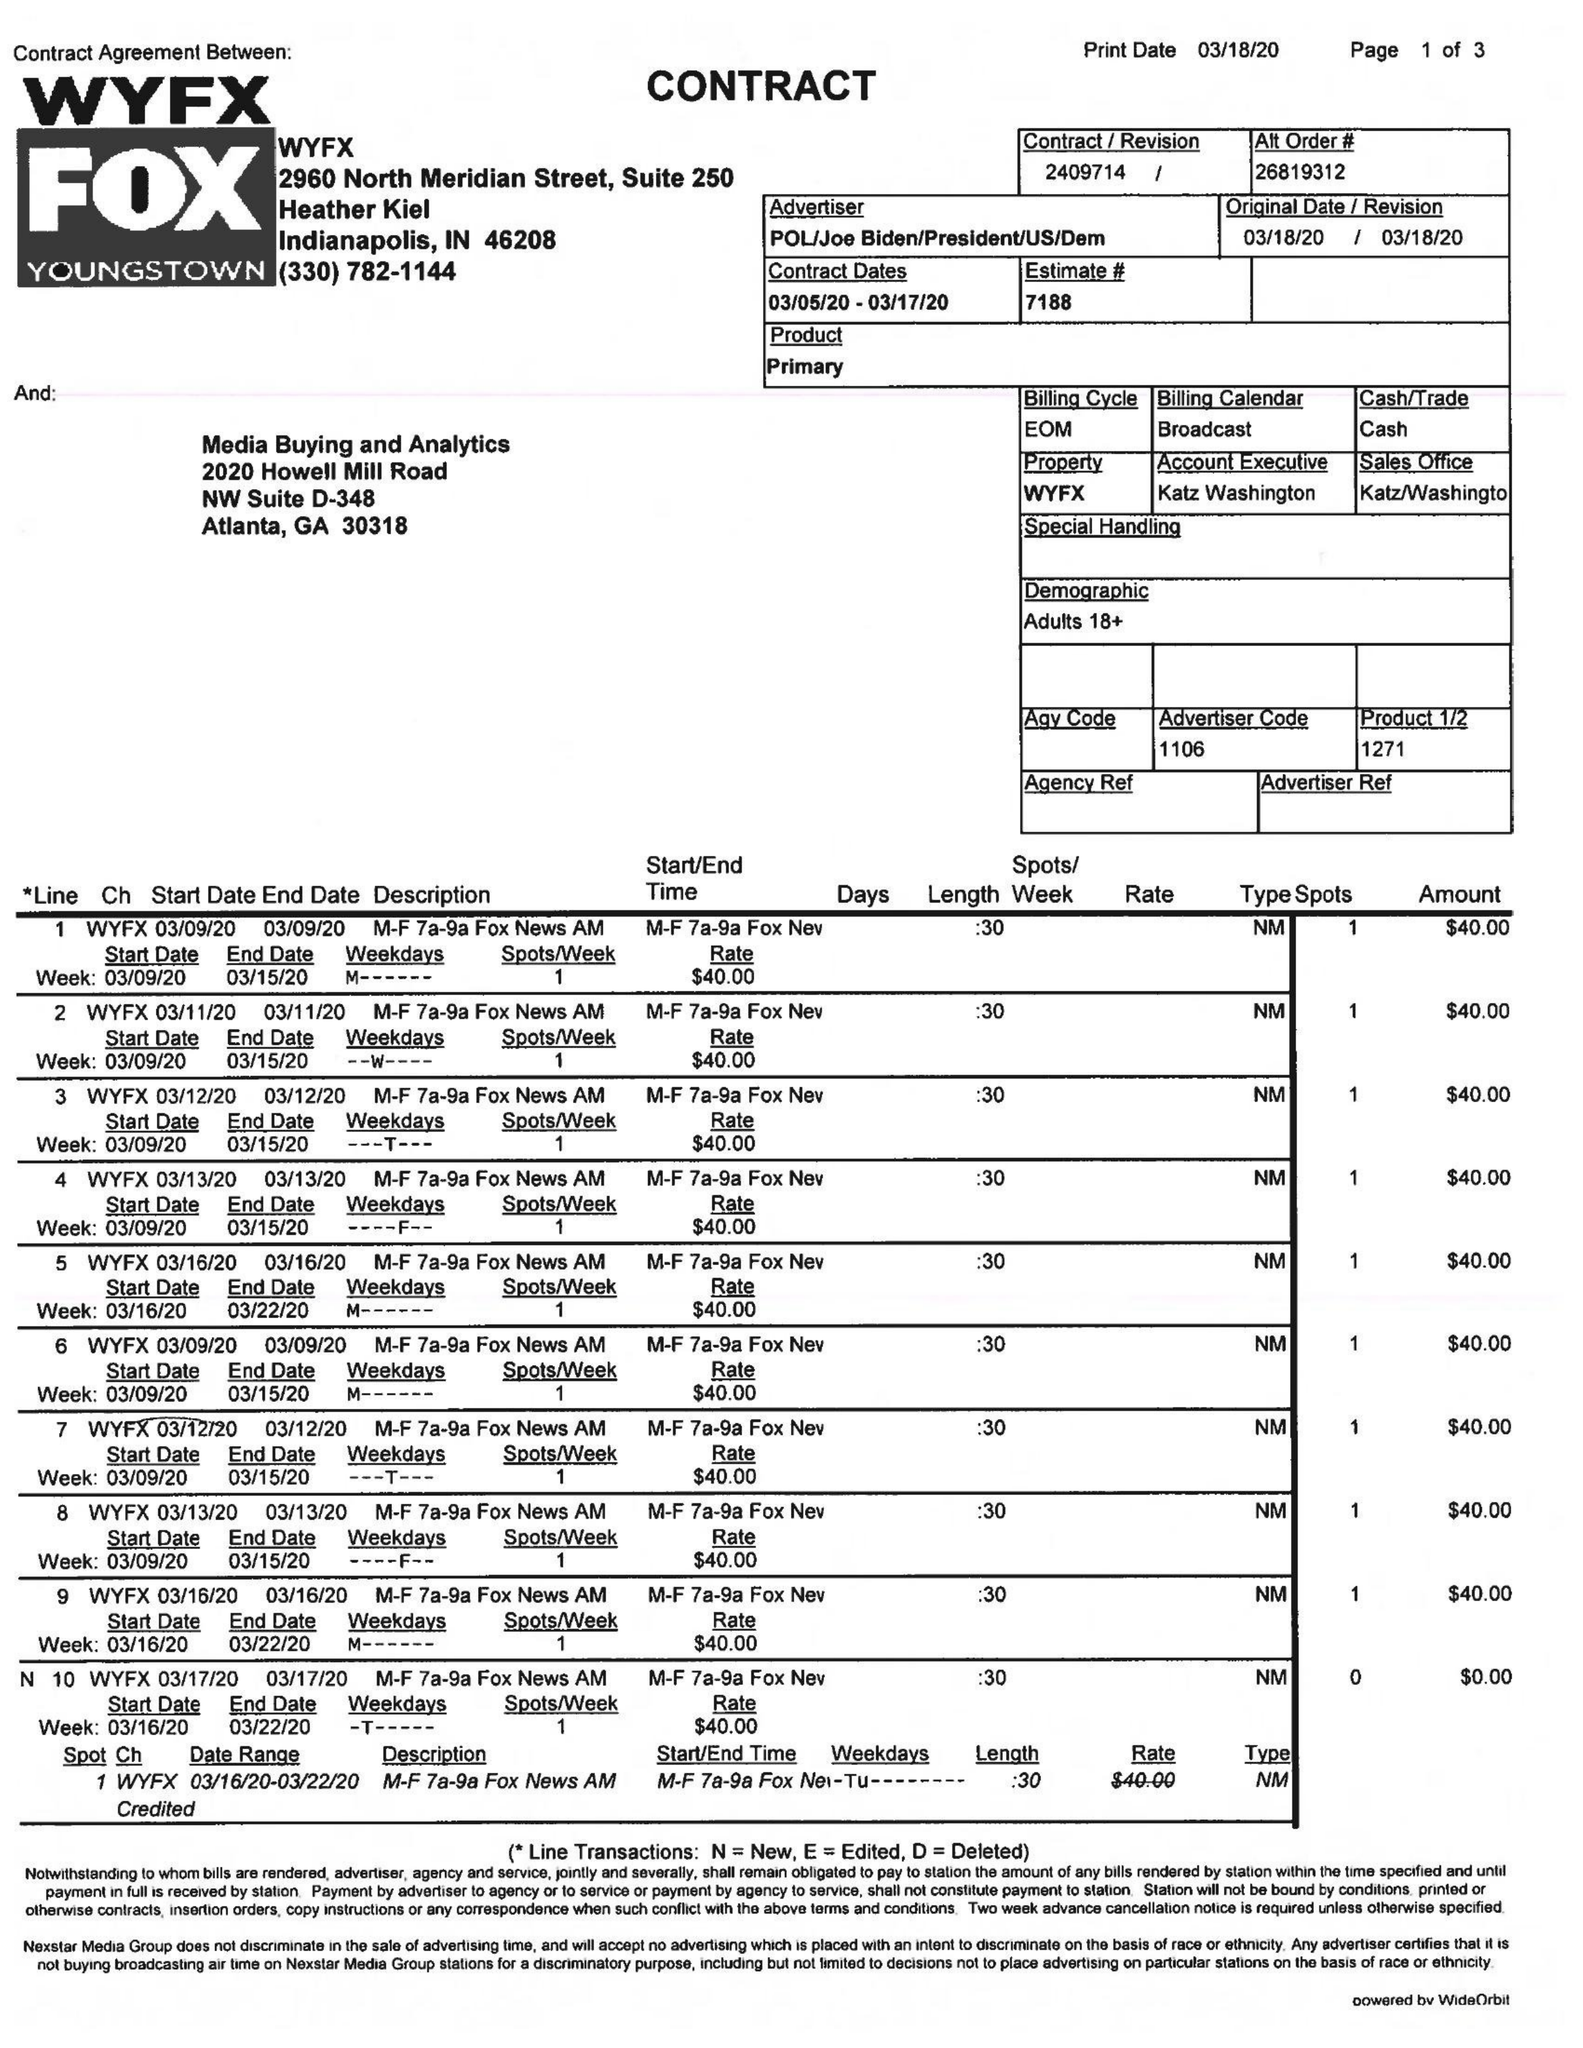What is the value for the flight_from?
Answer the question using a single word or phrase. 03/05/20 